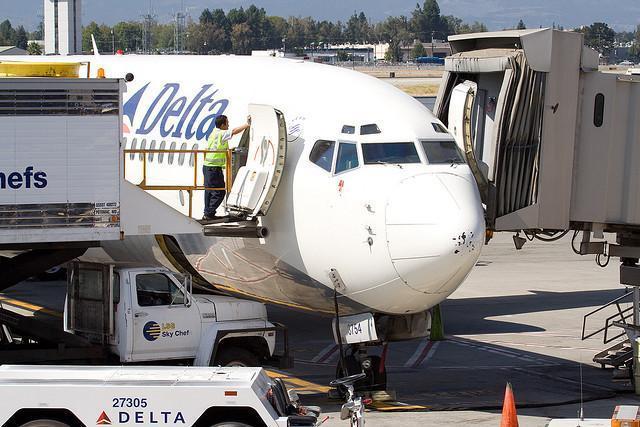How many trucks are there?
Give a very brief answer. 3. 